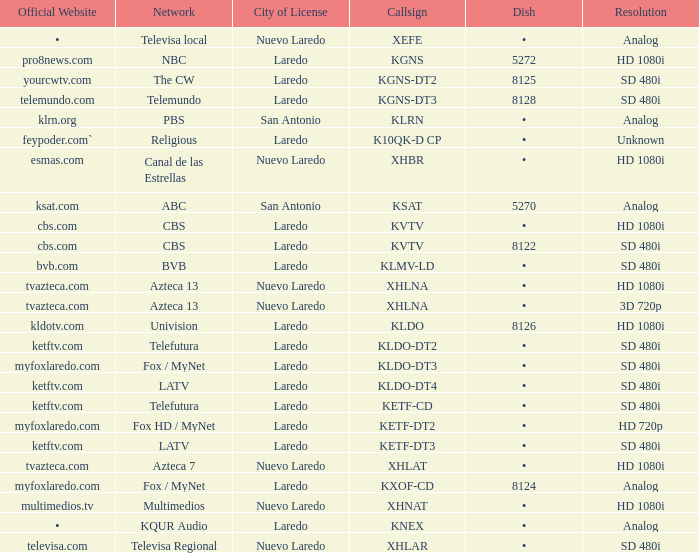Name the city of license with resolution of sd 480i and official website of telemundo.com Laredo. 